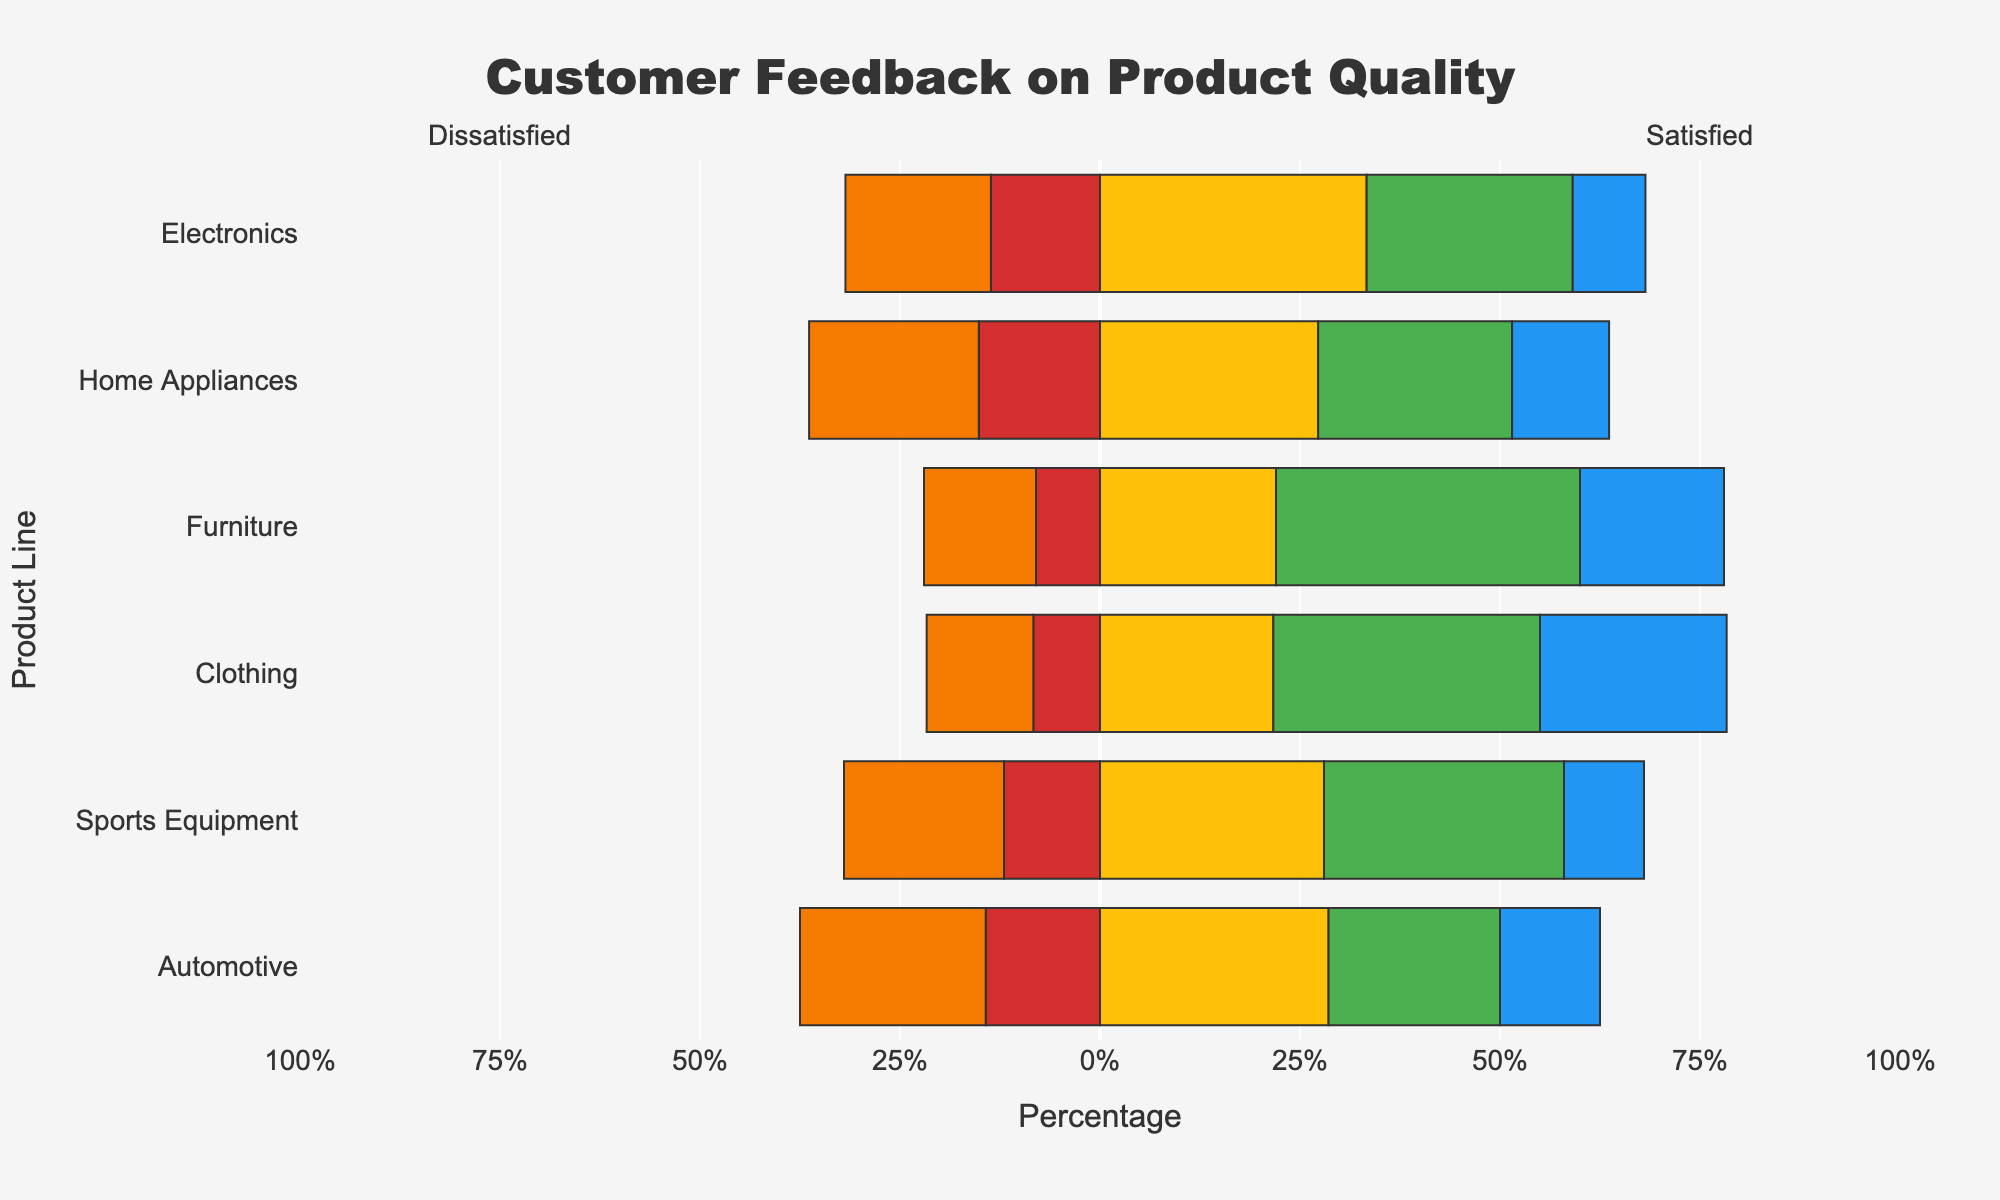What percentage of Electronics customers are satisfied or very satisfied combined? First, locate the "Electronics" bar on the chart. Then, sum the percentages of "Satisfied" and "Very Satisfied" segments within that bar. The total percentage is the sum of the portions represented by green ("Satisfied") and blue ("Very Satisfied") in the "Electronics" bar, which are 28.4% and 10.0%, respectively.
Answer: 38.4% Which product line has the highest percentage of dissatisfied customers? Compare the lengths of the "Very Dissatisfied" and "Dissatisfied" segments for each product line. The "Home Appliances" category has the longest combined sections for these negative feedbacks, with 25.5% "Dissatisfied" and 18.2% "Very Dissatisfied," making it the highest.
Answer: Home Appliances What is the total percentage of neutral feedback for Furniture and Clothing combined? Locate the "Neutral" segments for both Furniture and Clothing. Furniture has 22.1% while Clothing has 20.5%. Sum these two percentages to get the combined total.
Answer: 42.6% Which product line has the most balanced customer feedback, with percentages distributed more evenly across all categories? Evaluate each product line to determine which has the smallest extreme values and a more balanced distribution across all feedback categories. "Automotive" has neither excessively high positive nor negative feedback percentages and shows a more even spread across the categories.
Answer: Automotive What is the difference in the percentage of very satisfied customers between Clothing and Sports Equipment? Identify the "Very Satisfied" segments for both Clothing and Sports Equipment. Clothing has a "Very Satisfied" percentage of 22.6%, and Sports Equipment has 10.5%. Calculate the difference by subtracting 10.5% from 22.6%.
Answer: 12.1% Which product line has the lowest percentage of very dissatisfied customers, and what is that percentage? Compare the "Very Dissatisfied" segments across all product lines. Furniture has the smallest "Very Dissatisfied" percentage at 8.0%.
Answer: Furniture, 8.0% How does the percentage of satisfied feedback for Home Appliances compare to that of Clothing? Observe the "Satisfied" segments for Home Appliances and Clothing. Home Appliances has 29.2% satisfied feedback, and Clothing has 34.2%. Thus, Clothing has a higher percentage of satisfied feedback.
Answer: Clothing is higher What is the combined percentage of dissatisfied and very dissatisfied feedback for Sports Equipment? Find the "Dissatisfied" and "Very Dissatisfied" segments for Sports Equipment. The percentages are 24.0% and 14.3%, respectively. Add these percentages to get the combined total.
Answer: 38.3% Which product line has the highest percentage of neutral feedback? Compare the "Neutral" feedback segments for all product lines. Home Appliances has the highest percentage of neutral feedback at 27.8%.
Answer: Home Appliances What is the range (difference between the highest and lowest percentages) of very satisfied feedback across all product lines? Identify the "Very Satisfied" segments for all product lines. The highest is Clothing with 23.9%, and the lowest is Sports Equipment with 8.0%. Subtract the lowest percentage from the highest to find the range.
Answer: 15.9% 